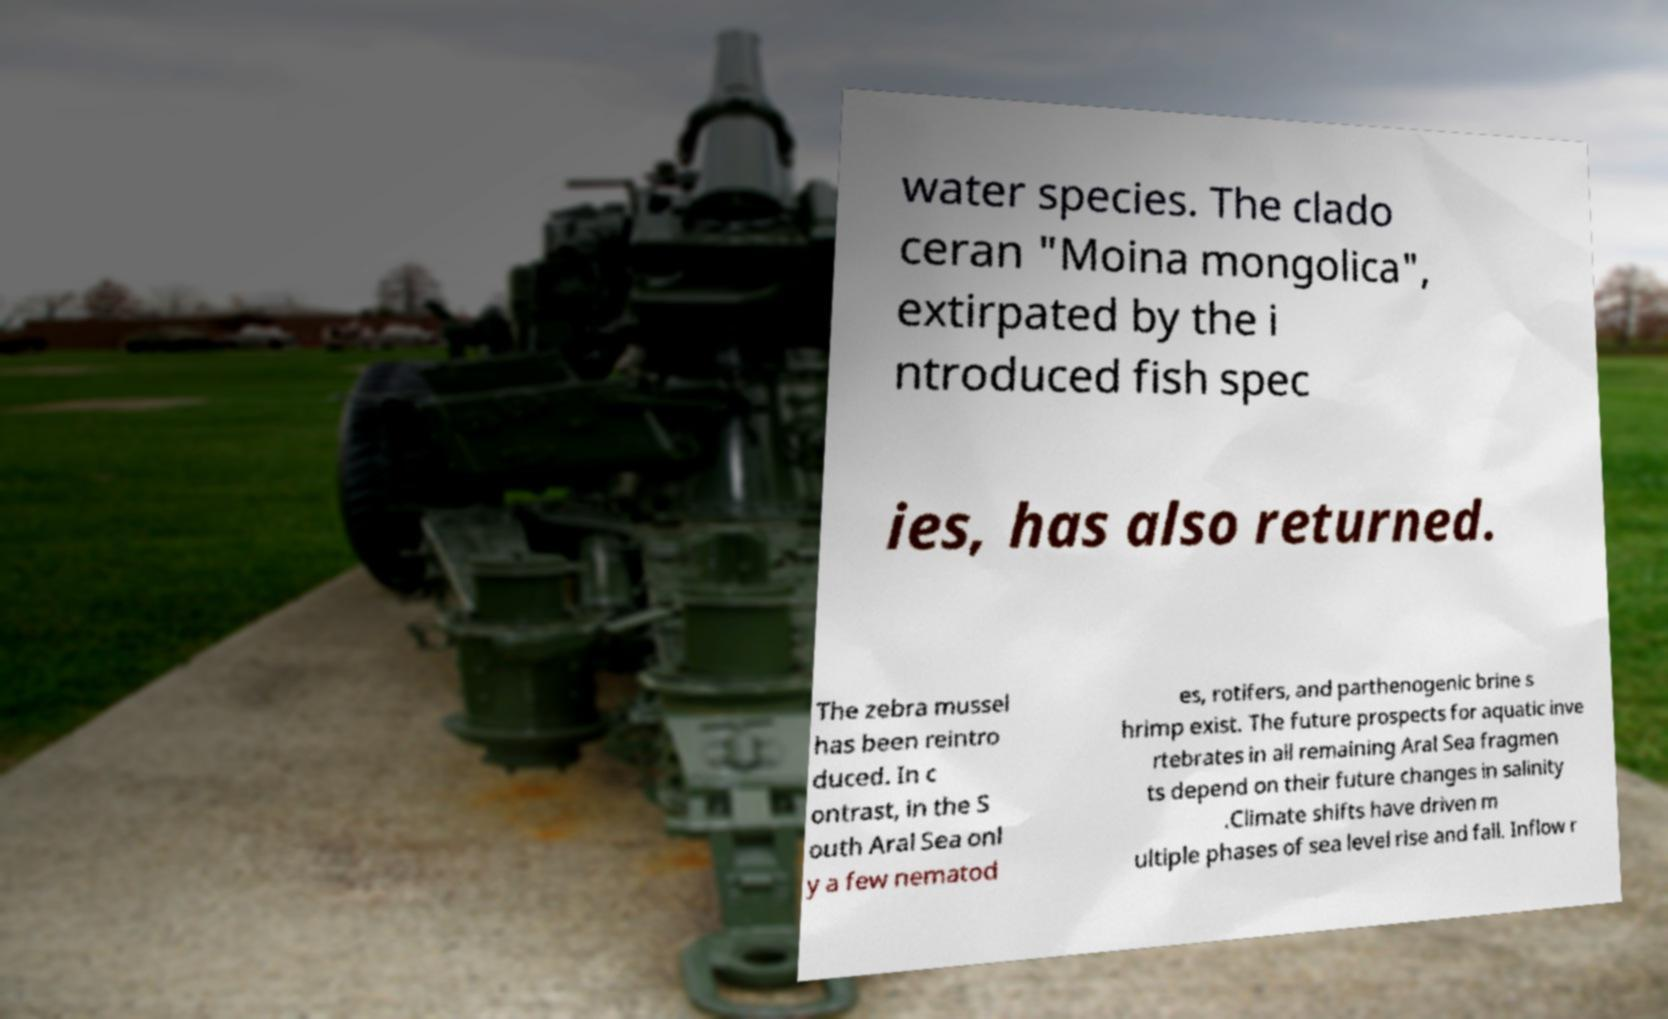What messages or text are displayed in this image? I need them in a readable, typed format. water species. The clado ceran "Moina mongolica", extirpated by the i ntroduced fish spec ies, has also returned. The zebra mussel has been reintro duced. In c ontrast, in the S outh Aral Sea onl y a few nematod es, rotifers, and parthenogenic brine s hrimp exist. The future prospects for aquatic inve rtebrates in all remaining Aral Sea fragmen ts depend on their future changes in salinity .Climate shifts have driven m ultiple phases of sea level rise and fall. Inflow r 